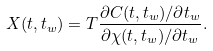Convert formula to latex. <formula><loc_0><loc_0><loc_500><loc_500>X ( t , t _ { w } ) = T \frac { \partial C ( t , t _ { w } ) / \partial t _ { w } } { \partial \chi ( t , t _ { w } ) / \partial t _ { w } } .</formula> 